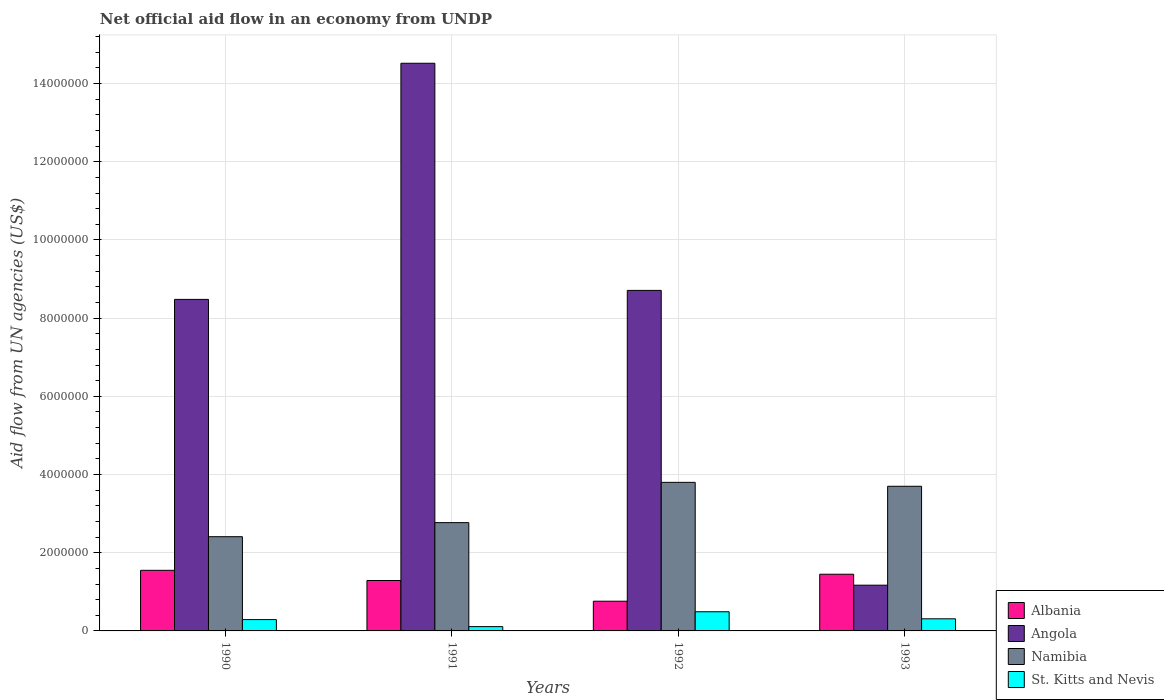Are the number of bars on each tick of the X-axis equal?
Make the answer very short. Yes. What is the net official aid flow in Albania in 1992?
Keep it short and to the point. 7.60e+05. Across all years, what is the maximum net official aid flow in Namibia?
Offer a terse response. 3.80e+06. Across all years, what is the minimum net official aid flow in Albania?
Provide a short and direct response. 7.60e+05. In which year was the net official aid flow in Angola maximum?
Give a very brief answer. 1991. In which year was the net official aid flow in Namibia minimum?
Ensure brevity in your answer.  1990. What is the total net official aid flow in Namibia in the graph?
Your response must be concise. 1.27e+07. What is the difference between the net official aid flow in Namibia in 1991 and that in 1993?
Your answer should be compact. -9.30e+05. What is the difference between the net official aid flow in Angola in 1991 and the net official aid flow in Namibia in 1990?
Offer a very short reply. 1.21e+07. What is the average net official aid flow in Angola per year?
Your answer should be very brief. 8.22e+06. In the year 1992, what is the difference between the net official aid flow in St. Kitts and Nevis and net official aid flow in Angola?
Keep it short and to the point. -8.22e+06. In how many years, is the net official aid flow in Namibia greater than 1200000 US$?
Your response must be concise. 4. What is the ratio of the net official aid flow in Namibia in 1991 to that in 1993?
Give a very brief answer. 0.75. Is the difference between the net official aid flow in St. Kitts and Nevis in 1991 and 1992 greater than the difference between the net official aid flow in Angola in 1991 and 1992?
Provide a short and direct response. No. What is the difference between the highest and the second highest net official aid flow in St. Kitts and Nevis?
Make the answer very short. 1.80e+05. What is the difference between the highest and the lowest net official aid flow in Albania?
Your answer should be compact. 7.90e+05. In how many years, is the net official aid flow in Namibia greater than the average net official aid flow in Namibia taken over all years?
Offer a very short reply. 2. Is the sum of the net official aid flow in St. Kitts and Nevis in 1990 and 1991 greater than the maximum net official aid flow in Albania across all years?
Make the answer very short. No. Is it the case that in every year, the sum of the net official aid flow in St. Kitts and Nevis and net official aid flow in Angola is greater than the sum of net official aid flow in Namibia and net official aid flow in Albania?
Your answer should be very brief. No. What does the 2nd bar from the left in 1991 represents?
Offer a very short reply. Angola. What does the 4th bar from the right in 1991 represents?
Your answer should be very brief. Albania. Is it the case that in every year, the sum of the net official aid flow in St. Kitts and Nevis and net official aid flow in Namibia is greater than the net official aid flow in Albania?
Your answer should be compact. Yes. How many bars are there?
Give a very brief answer. 16. How many years are there in the graph?
Offer a very short reply. 4. What is the difference between two consecutive major ticks on the Y-axis?
Your answer should be compact. 2.00e+06. Are the values on the major ticks of Y-axis written in scientific E-notation?
Give a very brief answer. No. Does the graph contain grids?
Make the answer very short. Yes. Where does the legend appear in the graph?
Offer a very short reply. Bottom right. How many legend labels are there?
Offer a very short reply. 4. How are the legend labels stacked?
Your answer should be very brief. Vertical. What is the title of the graph?
Provide a succinct answer. Net official aid flow in an economy from UNDP. Does "Sint Maarten (Dutch part)" appear as one of the legend labels in the graph?
Offer a terse response. No. What is the label or title of the Y-axis?
Make the answer very short. Aid flow from UN agencies (US$). What is the Aid flow from UN agencies (US$) of Albania in 1990?
Your answer should be compact. 1.55e+06. What is the Aid flow from UN agencies (US$) of Angola in 1990?
Give a very brief answer. 8.48e+06. What is the Aid flow from UN agencies (US$) of Namibia in 1990?
Give a very brief answer. 2.41e+06. What is the Aid flow from UN agencies (US$) in St. Kitts and Nevis in 1990?
Provide a succinct answer. 2.90e+05. What is the Aid flow from UN agencies (US$) in Albania in 1991?
Provide a short and direct response. 1.29e+06. What is the Aid flow from UN agencies (US$) in Angola in 1991?
Your answer should be very brief. 1.45e+07. What is the Aid flow from UN agencies (US$) in Namibia in 1991?
Your answer should be very brief. 2.77e+06. What is the Aid flow from UN agencies (US$) of St. Kitts and Nevis in 1991?
Give a very brief answer. 1.10e+05. What is the Aid flow from UN agencies (US$) of Albania in 1992?
Your response must be concise. 7.60e+05. What is the Aid flow from UN agencies (US$) of Angola in 1992?
Offer a terse response. 8.71e+06. What is the Aid flow from UN agencies (US$) in Namibia in 1992?
Your answer should be compact. 3.80e+06. What is the Aid flow from UN agencies (US$) of Albania in 1993?
Offer a very short reply. 1.45e+06. What is the Aid flow from UN agencies (US$) of Angola in 1993?
Your answer should be compact. 1.17e+06. What is the Aid flow from UN agencies (US$) in Namibia in 1993?
Give a very brief answer. 3.70e+06. Across all years, what is the maximum Aid flow from UN agencies (US$) of Albania?
Offer a terse response. 1.55e+06. Across all years, what is the maximum Aid flow from UN agencies (US$) of Angola?
Make the answer very short. 1.45e+07. Across all years, what is the maximum Aid flow from UN agencies (US$) of Namibia?
Provide a short and direct response. 3.80e+06. Across all years, what is the minimum Aid flow from UN agencies (US$) of Albania?
Offer a terse response. 7.60e+05. Across all years, what is the minimum Aid flow from UN agencies (US$) of Angola?
Your answer should be very brief. 1.17e+06. Across all years, what is the minimum Aid flow from UN agencies (US$) of Namibia?
Your answer should be compact. 2.41e+06. What is the total Aid flow from UN agencies (US$) of Albania in the graph?
Provide a succinct answer. 5.05e+06. What is the total Aid flow from UN agencies (US$) in Angola in the graph?
Offer a terse response. 3.29e+07. What is the total Aid flow from UN agencies (US$) of Namibia in the graph?
Keep it short and to the point. 1.27e+07. What is the total Aid flow from UN agencies (US$) of St. Kitts and Nevis in the graph?
Provide a short and direct response. 1.20e+06. What is the difference between the Aid flow from UN agencies (US$) in Albania in 1990 and that in 1991?
Provide a succinct answer. 2.60e+05. What is the difference between the Aid flow from UN agencies (US$) in Angola in 1990 and that in 1991?
Keep it short and to the point. -6.04e+06. What is the difference between the Aid flow from UN agencies (US$) in Namibia in 1990 and that in 1991?
Your answer should be compact. -3.60e+05. What is the difference between the Aid flow from UN agencies (US$) of Albania in 1990 and that in 1992?
Give a very brief answer. 7.90e+05. What is the difference between the Aid flow from UN agencies (US$) in Namibia in 1990 and that in 1992?
Ensure brevity in your answer.  -1.39e+06. What is the difference between the Aid flow from UN agencies (US$) in St. Kitts and Nevis in 1990 and that in 1992?
Ensure brevity in your answer.  -2.00e+05. What is the difference between the Aid flow from UN agencies (US$) of Angola in 1990 and that in 1993?
Offer a very short reply. 7.31e+06. What is the difference between the Aid flow from UN agencies (US$) in Namibia in 1990 and that in 1993?
Provide a short and direct response. -1.29e+06. What is the difference between the Aid flow from UN agencies (US$) of St. Kitts and Nevis in 1990 and that in 1993?
Offer a very short reply. -2.00e+04. What is the difference between the Aid flow from UN agencies (US$) in Albania in 1991 and that in 1992?
Ensure brevity in your answer.  5.30e+05. What is the difference between the Aid flow from UN agencies (US$) of Angola in 1991 and that in 1992?
Your answer should be very brief. 5.81e+06. What is the difference between the Aid flow from UN agencies (US$) in Namibia in 1991 and that in 1992?
Make the answer very short. -1.03e+06. What is the difference between the Aid flow from UN agencies (US$) in St. Kitts and Nevis in 1991 and that in 1992?
Your response must be concise. -3.80e+05. What is the difference between the Aid flow from UN agencies (US$) in Angola in 1991 and that in 1993?
Offer a terse response. 1.34e+07. What is the difference between the Aid flow from UN agencies (US$) in Namibia in 1991 and that in 1993?
Your answer should be very brief. -9.30e+05. What is the difference between the Aid flow from UN agencies (US$) of Albania in 1992 and that in 1993?
Provide a short and direct response. -6.90e+05. What is the difference between the Aid flow from UN agencies (US$) in Angola in 1992 and that in 1993?
Make the answer very short. 7.54e+06. What is the difference between the Aid flow from UN agencies (US$) of Namibia in 1992 and that in 1993?
Provide a succinct answer. 1.00e+05. What is the difference between the Aid flow from UN agencies (US$) of St. Kitts and Nevis in 1992 and that in 1993?
Your response must be concise. 1.80e+05. What is the difference between the Aid flow from UN agencies (US$) in Albania in 1990 and the Aid flow from UN agencies (US$) in Angola in 1991?
Keep it short and to the point. -1.30e+07. What is the difference between the Aid flow from UN agencies (US$) of Albania in 1990 and the Aid flow from UN agencies (US$) of Namibia in 1991?
Offer a very short reply. -1.22e+06. What is the difference between the Aid flow from UN agencies (US$) in Albania in 1990 and the Aid flow from UN agencies (US$) in St. Kitts and Nevis in 1991?
Keep it short and to the point. 1.44e+06. What is the difference between the Aid flow from UN agencies (US$) of Angola in 1990 and the Aid flow from UN agencies (US$) of Namibia in 1991?
Give a very brief answer. 5.71e+06. What is the difference between the Aid flow from UN agencies (US$) of Angola in 1990 and the Aid flow from UN agencies (US$) of St. Kitts and Nevis in 1991?
Your response must be concise. 8.37e+06. What is the difference between the Aid flow from UN agencies (US$) in Namibia in 1990 and the Aid flow from UN agencies (US$) in St. Kitts and Nevis in 1991?
Your answer should be compact. 2.30e+06. What is the difference between the Aid flow from UN agencies (US$) of Albania in 1990 and the Aid flow from UN agencies (US$) of Angola in 1992?
Keep it short and to the point. -7.16e+06. What is the difference between the Aid flow from UN agencies (US$) of Albania in 1990 and the Aid flow from UN agencies (US$) of Namibia in 1992?
Your answer should be very brief. -2.25e+06. What is the difference between the Aid flow from UN agencies (US$) in Albania in 1990 and the Aid flow from UN agencies (US$) in St. Kitts and Nevis in 1992?
Offer a terse response. 1.06e+06. What is the difference between the Aid flow from UN agencies (US$) in Angola in 1990 and the Aid flow from UN agencies (US$) in Namibia in 1992?
Your answer should be very brief. 4.68e+06. What is the difference between the Aid flow from UN agencies (US$) in Angola in 1990 and the Aid flow from UN agencies (US$) in St. Kitts and Nevis in 1992?
Keep it short and to the point. 7.99e+06. What is the difference between the Aid flow from UN agencies (US$) of Namibia in 1990 and the Aid flow from UN agencies (US$) of St. Kitts and Nevis in 1992?
Provide a succinct answer. 1.92e+06. What is the difference between the Aid flow from UN agencies (US$) of Albania in 1990 and the Aid flow from UN agencies (US$) of Angola in 1993?
Your answer should be very brief. 3.80e+05. What is the difference between the Aid flow from UN agencies (US$) in Albania in 1990 and the Aid flow from UN agencies (US$) in Namibia in 1993?
Provide a succinct answer. -2.15e+06. What is the difference between the Aid flow from UN agencies (US$) of Albania in 1990 and the Aid flow from UN agencies (US$) of St. Kitts and Nevis in 1993?
Provide a succinct answer. 1.24e+06. What is the difference between the Aid flow from UN agencies (US$) in Angola in 1990 and the Aid flow from UN agencies (US$) in Namibia in 1993?
Keep it short and to the point. 4.78e+06. What is the difference between the Aid flow from UN agencies (US$) in Angola in 1990 and the Aid flow from UN agencies (US$) in St. Kitts and Nevis in 1993?
Provide a short and direct response. 8.17e+06. What is the difference between the Aid flow from UN agencies (US$) in Namibia in 1990 and the Aid flow from UN agencies (US$) in St. Kitts and Nevis in 1993?
Offer a terse response. 2.10e+06. What is the difference between the Aid flow from UN agencies (US$) in Albania in 1991 and the Aid flow from UN agencies (US$) in Angola in 1992?
Offer a very short reply. -7.42e+06. What is the difference between the Aid flow from UN agencies (US$) in Albania in 1991 and the Aid flow from UN agencies (US$) in Namibia in 1992?
Your answer should be compact. -2.51e+06. What is the difference between the Aid flow from UN agencies (US$) in Albania in 1991 and the Aid flow from UN agencies (US$) in St. Kitts and Nevis in 1992?
Make the answer very short. 8.00e+05. What is the difference between the Aid flow from UN agencies (US$) in Angola in 1991 and the Aid flow from UN agencies (US$) in Namibia in 1992?
Provide a succinct answer. 1.07e+07. What is the difference between the Aid flow from UN agencies (US$) in Angola in 1991 and the Aid flow from UN agencies (US$) in St. Kitts and Nevis in 1992?
Offer a very short reply. 1.40e+07. What is the difference between the Aid flow from UN agencies (US$) of Namibia in 1991 and the Aid flow from UN agencies (US$) of St. Kitts and Nevis in 1992?
Give a very brief answer. 2.28e+06. What is the difference between the Aid flow from UN agencies (US$) of Albania in 1991 and the Aid flow from UN agencies (US$) of Namibia in 1993?
Keep it short and to the point. -2.41e+06. What is the difference between the Aid flow from UN agencies (US$) in Albania in 1991 and the Aid flow from UN agencies (US$) in St. Kitts and Nevis in 1993?
Offer a terse response. 9.80e+05. What is the difference between the Aid flow from UN agencies (US$) of Angola in 1991 and the Aid flow from UN agencies (US$) of Namibia in 1993?
Ensure brevity in your answer.  1.08e+07. What is the difference between the Aid flow from UN agencies (US$) in Angola in 1991 and the Aid flow from UN agencies (US$) in St. Kitts and Nevis in 1993?
Offer a very short reply. 1.42e+07. What is the difference between the Aid flow from UN agencies (US$) in Namibia in 1991 and the Aid flow from UN agencies (US$) in St. Kitts and Nevis in 1993?
Keep it short and to the point. 2.46e+06. What is the difference between the Aid flow from UN agencies (US$) in Albania in 1992 and the Aid flow from UN agencies (US$) in Angola in 1993?
Offer a very short reply. -4.10e+05. What is the difference between the Aid flow from UN agencies (US$) in Albania in 1992 and the Aid flow from UN agencies (US$) in Namibia in 1993?
Provide a succinct answer. -2.94e+06. What is the difference between the Aid flow from UN agencies (US$) in Albania in 1992 and the Aid flow from UN agencies (US$) in St. Kitts and Nevis in 1993?
Your answer should be compact. 4.50e+05. What is the difference between the Aid flow from UN agencies (US$) of Angola in 1992 and the Aid flow from UN agencies (US$) of Namibia in 1993?
Give a very brief answer. 5.01e+06. What is the difference between the Aid flow from UN agencies (US$) of Angola in 1992 and the Aid flow from UN agencies (US$) of St. Kitts and Nevis in 1993?
Ensure brevity in your answer.  8.40e+06. What is the difference between the Aid flow from UN agencies (US$) in Namibia in 1992 and the Aid flow from UN agencies (US$) in St. Kitts and Nevis in 1993?
Ensure brevity in your answer.  3.49e+06. What is the average Aid flow from UN agencies (US$) of Albania per year?
Your answer should be compact. 1.26e+06. What is the average Aid flow from UN agencies (US$) in Angola per year?
Provide a succinct answer. 8.22e+06. What is the average Aid flow from UN agencies (US$) of Namibia per year?
Keep it short and to the point. 3.17e+06. What is the average Aid flow from UN agencies (US$) in St. Kitts and Nevis per year?
Provide a short and direct response. 3.00e+05. In the year 1990, what is the difference between the Aid flow from UN agencies (US$) in Albania and Aid flow from UN agencies (US$) in Angola?
Provide a succinct answer. -6.93e+06. In the year 1990, what is the difference between the Aid flow from UN agencies (US$) of Albania and Aid flow from UN agencies (US$) of Namibia?
Offer a terse response. -8.60e+05. In the year 1990, what is the difference between the Aid flow from UN agencies (US$) of Albania and Aid flow from UN agencies (US$) of St. Kitts and Nevis?
Give a very brief answer. 1.26e+06. In the year 1990, what is the difference between the Aid flow from UN agencies (US$) in Angola and Aid flow from UN agencies (US$) in Namibia?
Your answer should be compact. 6.07e+06. In the year 1990, what is the difference between the Aid flow from UN agencies (US$) in Angola and Aid flow from UN agencies (US$) in St. Kitts and Nevis?
Your answer should be compact. 8.19e+06. In the year 1990, what is the difference between the Aid flow from UN agencies (US$) in Namibia and Aid flow from UN agencies (US$) in St. Kitts and Nevis?
Give a very brief answer. 2.12e+06. In the year 1991, what is the difference between the Aid flow from UN agencies (US$) of Albania and Aid flow from UN agencies (US$) of Angola?
Ensure brevity in your answer.  -1.32e+07. In the year 1991, what is the difference between the Aid flow from UN agencies (US$) of Albania and Aid flow from UN agencies (US$) of Namibia?
Your answer should be very brief. -1.48e+06. In the year 1991, what is the difference between the Aid flow from UN agencies (US$) in Albania and Aid flow from UN agencies (US$) in St. Kitts and Nevis?
Ensure brevity in your answer.  1.18e+06. In the year 1991, what is the difference between the Aid flow from UN agencies (US$) in Angola and Aid flow from UN agencies (US$) in Namibia?
Your answer should be very brief. 1.18e+07. In the year 1991, what is the difference between the Aid flow from UN agencies (US$) of Angola and Aid flow from UN agencies (US$) of St. Kitts and Nevis?
Your answer should be very brief. 1.44e+07. In the year 1991, what is the difference between the Aid flow from UN agencies (US$) in Namibia and Aid flow from UN agencies (US$) in St. Kitts and Nevis?
Offer a terse response. 2.66e+06. In the year 1992, what is the difference between the Aid flow from UN agencies (US$) of Albania and Aid flow from UN agencies (US$) of Angola?
Provide a succinct answer. -7.95e+06. In the year 1992, what is the difference between the Aid flow from UN agencies (US$) of Albania and Aid flow from UN agencies (US$) of Namibia?
Offer a terse response. -3.04e+06. In the year 1992, what is the difference between the Aid flow from UN agencies (US$) in Angola and Aid flow from UN agencies (US$) in Namibia?
Ensure brevity in your answer.  4.91e+06. In the year 1992, what is the difference between the Aid flow from UN agencies (US$) in Angola and Aid flow from UN agencies (US$) in St. Kitts and Nevis?
Make the answer very short. 8.22e+06. In the year 1992, what is the difference between the Aid flow from UN agencies (US$) in Namibia and Aid flow from UN agencies (US$) in St. Kitts and Nevis?
Offer a very short reply. 3.31e+06. In the year 1993, what is the difference between the Aid flow from UN agencies (US$) of Albania and Aid flow from UN agencies (US$) of Angola?
Your answer should be very brief. 2.80e+05. In the year 1993, what is the difference between the Aid flow from UN agencies (US$) in Albania and Aid flow from UN agencies (US$) in Namibia?
Offer a very short reply. -2.25e+06. In the year 1993, what is the difference between the Aid flow from UN agencies (US$) of Albania and Aid flow from UN agencies (US$) of St. Kitts and Nevis?
Your answer should be compact. 1.14e+06. In the year 1993, what is the difference between the Aid flow from UN agencies (US$) of Angola and Aid flow from UN agencies (US$) of Namibia?
Offer a terse response. -2.53e+06. In the year 1993, what is the difference between the Aid flow from UN agencies (US$) in Angola and Aid flow from UN agencies (US$) in St. Kitts and Nevis?
Make the answer very short. 8.60e+05. In the year 1993, what is the difference between the Aid flow from UN agencies (US$) of Namibia and Aid flow from UN agencies (US$) of St. Kitts and Nevis?
Keep it short and to the point. 3.39e+06. What is the ratio of the Aid flow from UN agencies (US$) in Albania in 1990 to that in 1991?
Provide a succinct answer. 1.2. What is the ratio of the Aid flow from UN agencies (US$) in Angola in 1990 to that in 1991?
Provide a succinct answer. 0.58. What is the ratio of the Aid flow from UN agencies (US$) of Namibia in 1990 to that in 1991?
Make the answer very short. 0.87. What is the ratio of the Aid flow from UN agencies (US$) of St. Kitts and Nevis in 1990 to that in 1991?
Give a very brief answer. 2.64. What is the ratio of the Aid flow from UN agencies (US$) of Albania in 1990 to that in 1992?
Keep it short and to the point. 2.04. What is the ratio of the Aid flow from UN agencies (US$) in Angola in 1990 to that in 1992?
Your answer should be very brief. 0.97. What is the ratio of the Aid flow from UN agencies (US$) of Namibia in 1990 to that in 1992?
Your answer should be very brief. 0.63. What is the ratio of the Aid flow from UN agencies (US$) of St. Kitts and Nevis in 1990 to that in 1992?
Keep it short and to the point. 0.59. What is the ratio of the Aid flow from UN agencies (US$) of Albania in 1990 to that in 1993?
Ensure brevity in your answer.  1.07. What is the ratio of the Aid flow from UN agencies (US$) of Angola in 1990 to that in 1993?
Make the answer very short. 7.25. What is the ratio of the Aid flow from UN agencies (US$) of Namibia in 1990 to that in 1993?
Provide a succinct answer. 0.65. What is the ratio of the Aid flow from UN agencies (US$) of St. Kitts and Nevis in 1990 to that in 1993?
Provide a succinct answer. 0.94. What is the ratio of the Aid flow from UN agencies (US$) in Albania in 1991 to that in 1992?
Make the answer very short. 1.7. What is the ratio of the Aid flow from UN agencies (US$) in Angola in 1991 to that in 1992?
Keep it short and to the point. 1.67. What is the ratio of the Aid flow from UN agencies (US$) in Namibia in 1991 to that in 1992?
Keep it short and to the point. 0.73. What is the ratio of the Aid flow from UN agencies (US$) in St. Kitts and Nevis in 1991 to that in 1992?
Provide a succinct answer. 0.22. What is the ratio of the Aid flow from UN agencies (US$) of Albania in 1991 to that in 1993?
Make the answer very short. 0.89. What is the ratio of the Aid flow from UN agencies (US$) of Angola in 1991 to that in 1993?
Offer a terse response. 12.41. What is the ratio of the Aid flow from UN agencies (US$) in Namibia in 1991 to that in 1993?
Your answer should be compact. 0.75. What is the ratio of the Aid flow from UN agencies (US$) in St. Kitts and Nevis in 1991 to that in 1993?
Ensure brevity in your answer.  0.35. What is the ratio of the Aid flow from UN agencies (US$) in Albania in 1992 to that in 1993?
Offer a terse response. 0.52. What is the ratio of the Aid flow from UN agencies (US$) in Angola in 1992 to that in 1993?
Offer a very short reply. 7.44. What is the ratio of the Aid flow from UN agencies (US$) of St. Kitts and Nevis in 1992 to that in 1993?
Give a very brief answer. 1.58. What is the difference between the highest and the second highest Aid flow from UN agencies (US$) of Angola?
Offer a terse response. 5.81e+06. What is the difference between the highest and the second highest Aid flow from UN agencies (US$) of St. Kitts and Nevis?
Your answer should be very brief. 1.80e+05. What is the difference between the highest and the lowest Aid flow from UN agencies (US$) of Albania?
Offer a very short reply. 7.90e+05. What is the difference between the highest and the lowest Aid flow from UN agencies (US$) in Angola?
Provide a succinct answer. 1.34e+07. What is the difference between the highest and the lowest Aid flow from UN agencies (US$) of Namibia?
Ensure brevity in your answer.  1.39e+06. 